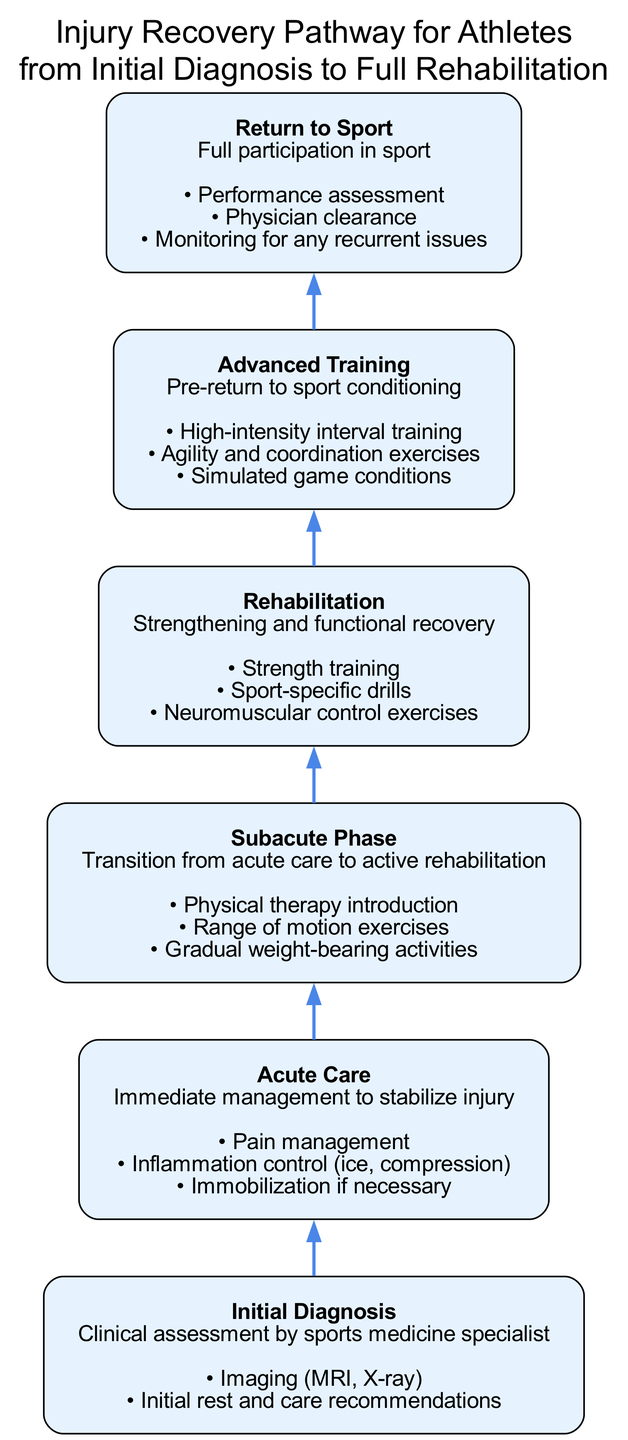What is the initial stage of the recovery pathway? The initial stage listed in the diagram is "Initial Diagnosis." It is the first point in the flow chart and represents the starting point of the recovery process.
Answer: Initial Diagnosis How many stages are there in the recovery pathway? By counting all the stages in the diagram, there are six distinct stages: Initial Diagnosis, Acute Care, Subacute Phase, Rehabilitation, Advanced Training, and Return to Sport.
Answer: 6 What action is included in the Acute Care stage? The diagram specifies several actions during the Acute Care stage, one of which is "Pain management." This indicates the focus of this stage on immediate management to stabilize an injury.
Answer: Pain management Which stage follows the Subacute Phase? The diagram shows a direct flow from the Subacute Phase to the Rehabilitation stage, indicating that after Subacute care, the next step is to focus more on rehabilitation efforts.
Answer: Rehabilitation What types of exercises are introduced in the Rehabilitation stage? Within the Rehabilitation stage, the diagram details "Strength training," "Sport-specific drills," and "Neuromuscular control exercises" as part of the recovery efforts, highlighting the focus on building strength and specific skills.
Answer: Strength training What is required before returning to sport? The last stage of the diagram specifies that "Physician clearance" is necessary prior to the athlete's return to full participation in the sport, indicating the importance of medical approval in the recovery process.
Answer: Physician clearance What actions are associated with the Advanced Training stage? The diagram outlines several actions in the Advanced Training stage, including "High-intensity interval training" and "Agility and coordination exercises," signifying activities aimed at preparing the athlete for a return to competition.
Answer: High-intensity interval training What is the primary goal of the Initial Diagnosis stage? The purpose of the Initial Diagnosis stage is to perform a "Clinical assessment by sports medicine specialist," as stated in the diagram, aimed at determining the nature of the injury and planning the recovery pathway.
Answer: Clinical assessment by sports medicine specialist 